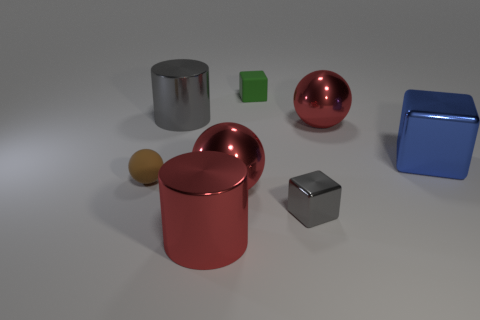What is the shape of the green thing that is made of the same material as the small brown thing?
Offer a terse response. Cube. Are there any small gray blocks to the left of the brown rubber thing?
Provide a short and direct response. No. Is the number of tiny gray metallic blocks that are right of the small gray object less than the number of green matte objects?
Ensure brevity in your answer.  Yes. What is the material of the blue block?
Give a very brief answer. Metal. The tiny rubber block is what color?
Your answer should be compact. Green. The metal object that is both to the right of the tiny green cube and in front of the brown matte object is what color?
Your response must be concise. Gray. Is there anything else that has the same material as the tiny sphere?
Your answer should be very brief. Yes. Does the green object have the same material as the small ball in front of the big blue cube?
Your response must be concise. Yes. How big is the green matte object right of the metal cylinder in front of the small gray metallic cube?
Provide a short and direct response. Small. Are there any other things of the same color as the small shiny thing?
Give a very brief answer. Yes. 